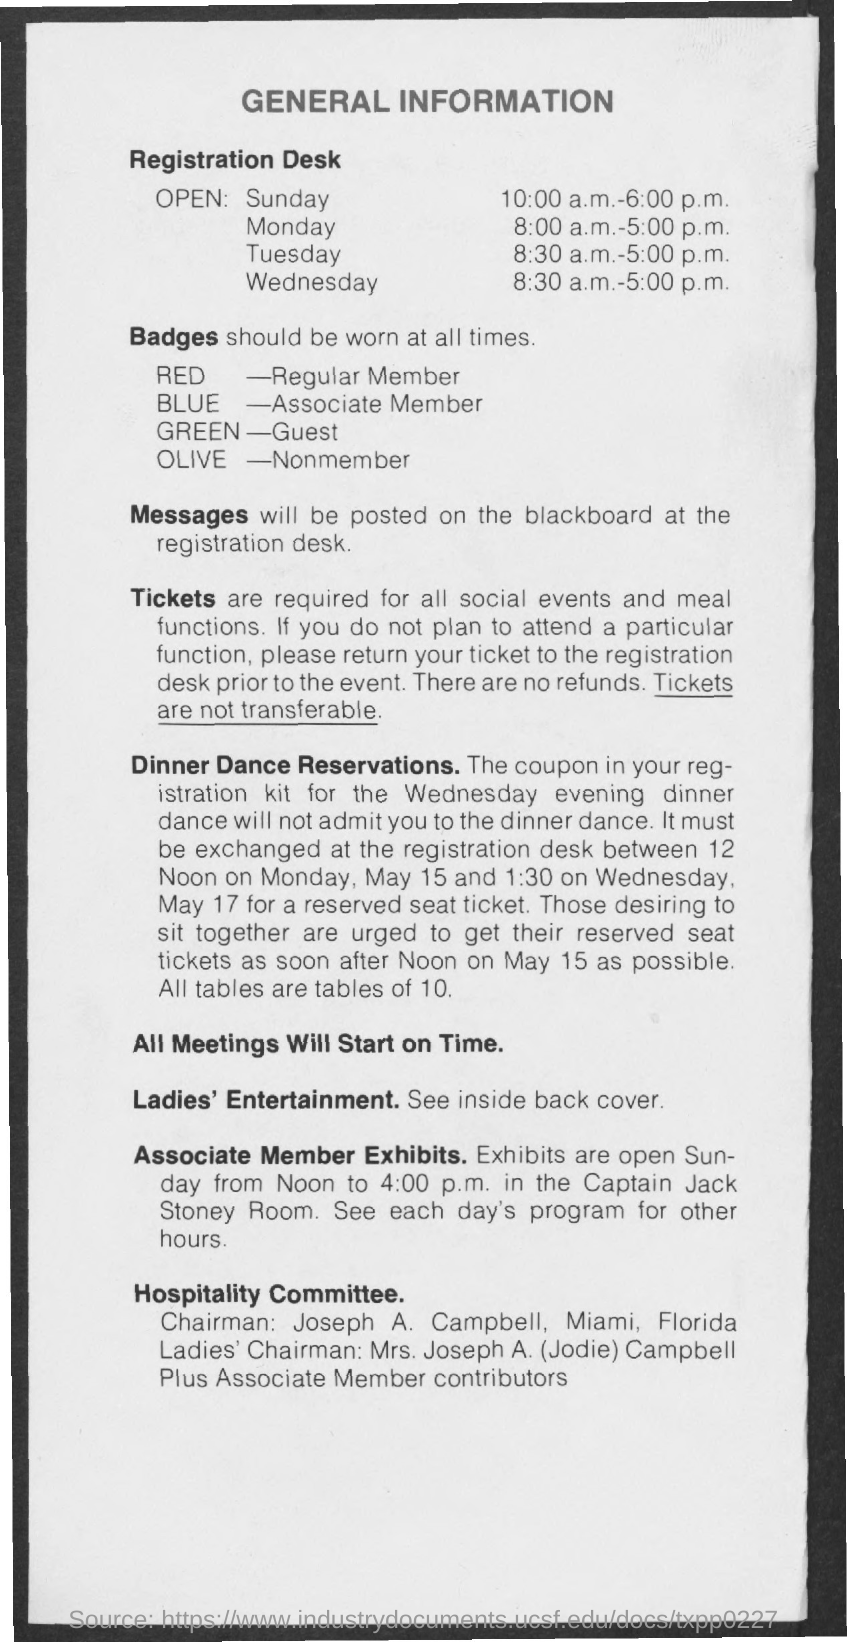Indicate a few pertinent items in this graphic. The red badge indicates that the person is a regular member. The olive badge signifies that the individual is not a member. The green badge indicates that the person wearing it is a guest. The blue badge indicates that the individual is an associate member. 